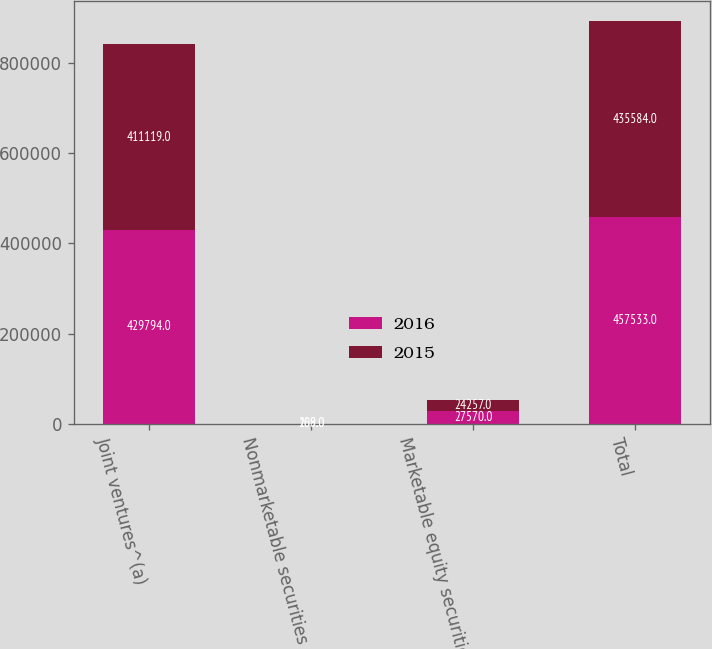<chart> <loc_0><loc_0><loc_500><loc_500><stacked_bar_chart><ecel><fcel>Joint ventures^(a)<fcel>Nonmarketable securities<fcel>Marketable equity securities<fcel>Total<nl><fcel>2016<fcel>429794<fcel>169<fcel>27570<fcel>457533<nl><fcel>2015<fcel>411119<fcel>208<fcel>24257<fcel>435584<nl></chart> 